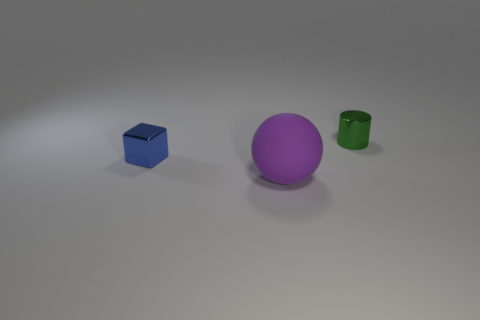Add 2 big yellow shiny objects. How many objects exist? 5 Subtract all balls. How many objects are left? 2 Subtract 0 gray balls. How many objects are left? 3 Subtract all green cylinders. Subtract all tiny metallic things. How many objects are left? 0 Add 1 large rubber spheres. How many large rubber spheres are left? 2 Add 3 large brown rubber things. How many large brown rubber things exist? 3 